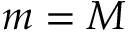<formula> <loc_0><loc_0><loc_500><loc_500>m = M</formula> 